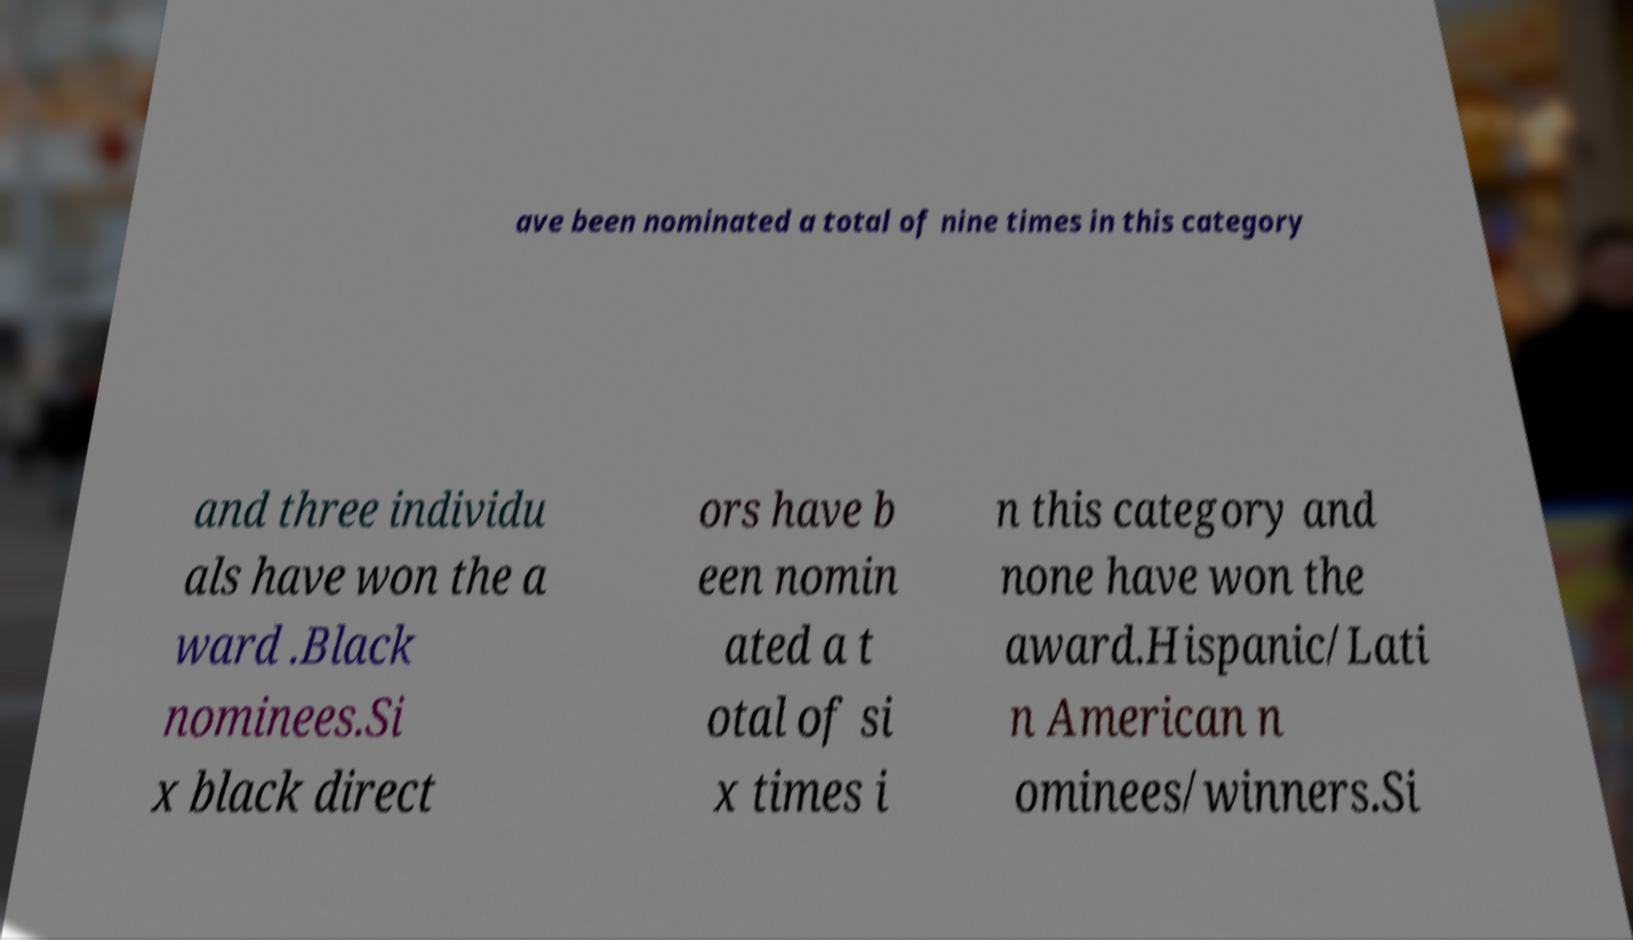Could you assist in decoding the text presented in this image and type it out clearly? ave been nominated a total of nine times in this category and three individu als have won the a ward .Black nominees.Si x black direct ors have b een nomin ated a t otal of si x times i n this category and none have won the award.Hispanic/Lati n American n ominees/winners.Si 